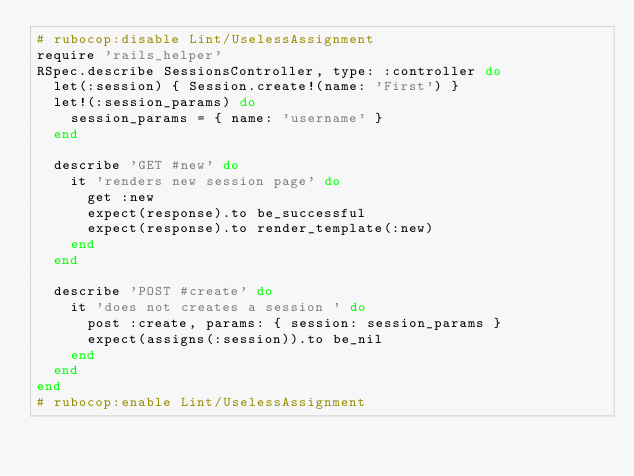Convert code to text. <code><loc_0><loc_0><loc_500><loc_500><_Ruby_># rubocop:disable Lint/UselessAssignment
require 'rails_helper'
RSpec.describe SessionsController, type: :controller do
  let(:session) { Session.create!(name: 'First') }
  let!(:session_params) do
    session_params = { name: 'username' }
  end

  describe 'GET #new' do
    it 'renders new session page' do
      get :new
      expect(response).to be_successful
      expect(response).to render_template(:new)
    end
  end

  describe 'POST #create' do
    it 'does not creates a session ' do
      post :create, params: { session: session_params }
      expect(assigns(:session)).to be_nil
    end
  end
end
# rubocop:enable Lint/UselessAssignment
</code> 